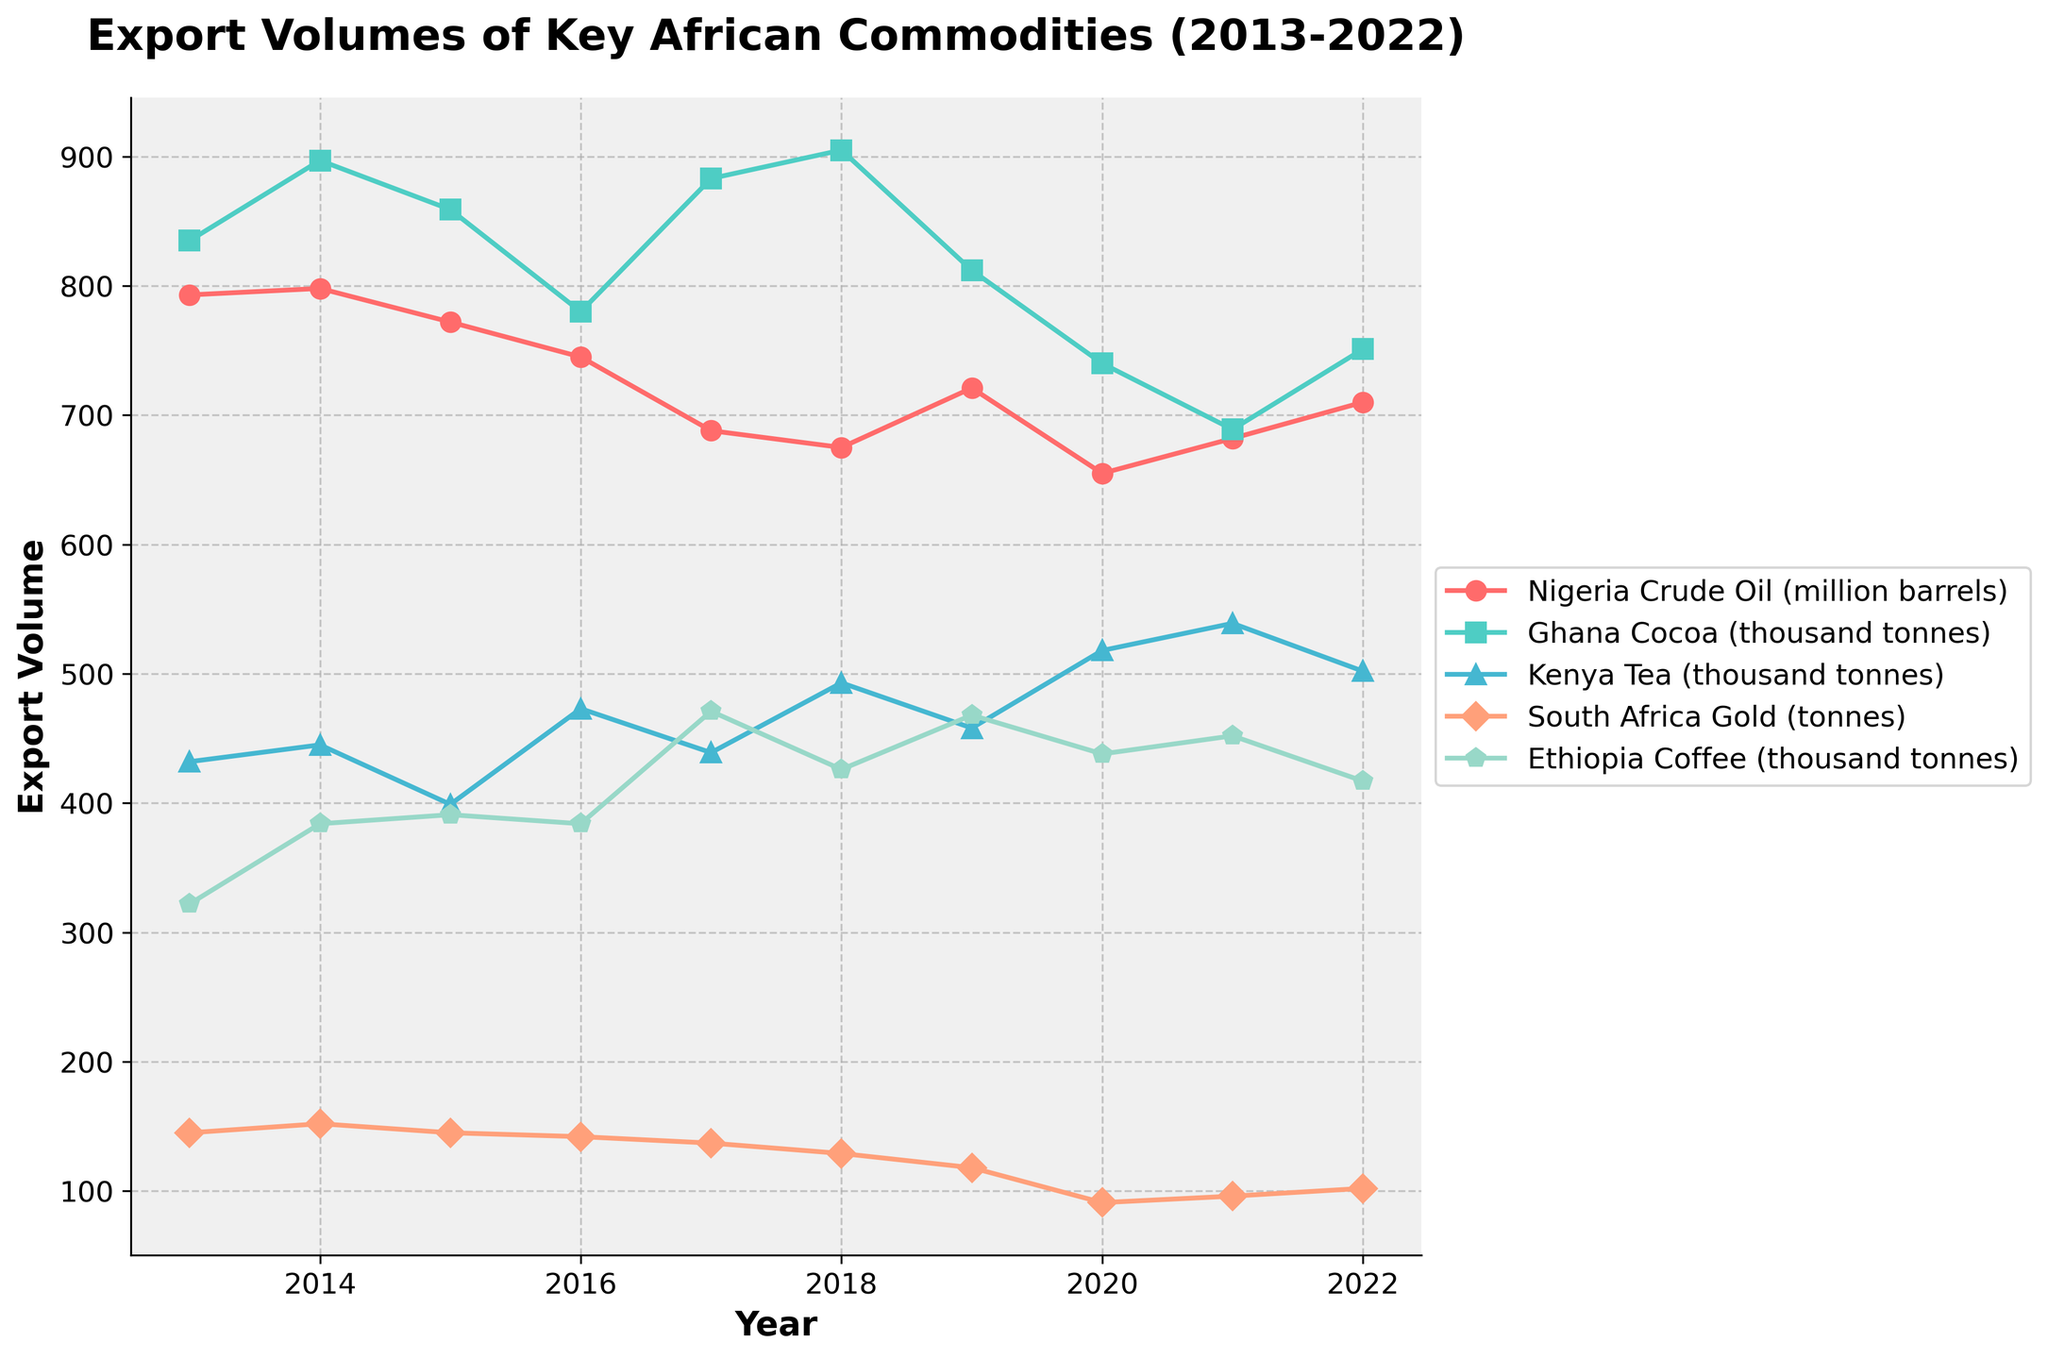What is the trend of Nigeria's crude oil exports over the past decade? Over the past decade, Nigeria’s crude oil export volume has a declining trend initially from 793 million barrels in 2013 to 655 million barrels in 2020 but shows a slight increase towards 710 million barrels in 2022.
Answer: Declining, then slightly increasing How did South Africa's gold exports change from 2013 to 2022? South Africa’s gold exports showed a general decline from 145 tonnes in 2013 to 96 tonnes in 2021, before showing a slight increase to 102 tonnes in 2022.
Answer: Decreased Which commodity had the highest export volume in 2022? In 2022, Ghana's cocoa export had the highest volume, reaching 751 thousand tonnes.
Answer: Ghana Cocoa Compare the export volume of Ethiopian coffee in 2016 and 2018. Which year had a higher export volume and by how much? Ethiopian coffee exports were 384 thousand tonnes in 2016 and 426 thousand tonnes in 2018. The export volume in 2018 was higher by 42 thousand tonnes.
Answer: 2018, by 42 thousand tonnes What are the trends in Kenya's tea exports from 2013 to 2022? The export volume of Kenya’s tea generally increased from 432 thousand tonnes in 2013, reaching a peak of 539 thousand tonnes in 2021, then slightly decreased to 502 thousand tonnes in 2022.
Answer: Increasing, then slight decrease Between 2021 and 2022, which country saw the largest increase in export volume of their key commodity? The largest increase in export volume between 2021 and 2022 occurred for Nigeria’s crude oil, which increased from 682 million barrels to 710 million barrels, showing an increase of 28 million barrels.
Answer: Nigeria, by 28 million barrels For which year did Ghana record the highest cocoa export volumes and what was the volume? Ghana recorded the highest cocoa export volumes in 2018, with a volume of 905 thousand tonnes.
Answer: 2018, 905 thousand tonnes Calculate the average annual export volume of crude oil from Nigeria over the decade. The average annual export volume of crude oil from Nigeria can be calculated by summing the yearly export volumes from 2013 to 2022 (793 + 798 + 772 + 745 + 688 + 675 + 721 + 655 + 682 + 710 = 7239) and dividing by the number of years (10). Therefore, the average annual export volume is 7239 / 10 = 723.9 million barrels.
Answer: 723.9 million barrels How does the export volume of Ethiopian coffee in 2020 compare to the export volume of Kenyan tea in the same year? In 2020, the export volume of Ethiopian coffee was 438 thousand tonnes, while Kenyan tea's export volume was 518 thousand tonnes. Kenyan tea exports were higher by 80 thousand tonnes.
Answer: Kenyan tea, by 80 thousand tonnes What color and marker represent South Africa’s gold exports in the plot? In the plot, South Africa’s gold exports are represented by an orange line with diamond-shaped markers.
Answer: Orange, diamond-shaped markers 